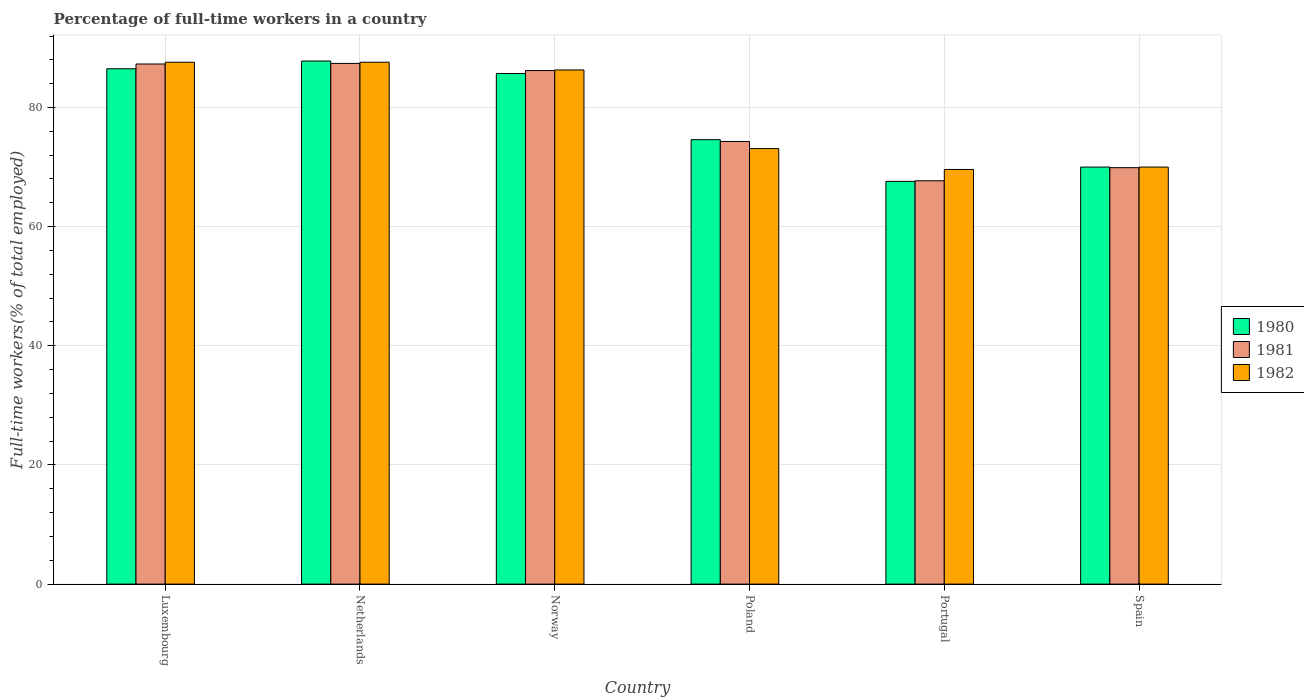How many groups of bars are there?
Provide a short and direct response. 6. Are the number of bars on each tick of the X-axis equal?
Keep it short and to the point. Yes. How many bars are there on the 2nd tick from the left?
Give a very brief answer. 3. What is the percentage of full-time workers in 1981 in Luxembourg?
Offer a very short reply. 87.3. Across all countries, what is the maximum percentage of full-time workers in 1981?
Provide a short and direct response. 87.4. Across all countries, what is the minimum percentage of full-time workers in 1982?
Keep it short and to the point. 69.6. In which country was the percentage of full-time workers in 1980 minimum?
Your answer should be compact. Portugal. What is the total percentage of full-time workers in 1980 in the graph?
Your response must be concise. 472.2. What is the difference between the percentage of full-time workers in 1981 in Luxembourg and that in Spain?
Offer a very short reply. 17.4. What is the difference between the percentage of full-time workers in 1980 in Portugal and the percentage of full-time workers in 1981 in Netherlands?
Give a very brief answer. -19.8. What is the average percentage of full-time workers in 1980 per country?
Provide a succinct answer. 78.7. What is the difference between the percentage of full-time workers of/in 1980 and percentage of full-time workers of/in 1981 in Poland?
Your answer should be compact. 0.3. What is the ratio of the percentage of full-time workers in 1981 in Poland to that in Spain?
Provide a short and direct response. 1.06. What is the difference between the highest and the second highest percentage of full-time workers in 1980?
Your answer should be very brief. -0.8. What is the difference between the highest and the lowest percentage of full-time workers in 1980?
Provide a short and direct response. 20.2. What does the 2nd bar from the left in Poland represents?
Provide a short and direct response. 1981. Are all the bars in the graph horizontal?
Offer a terse response. No. What is the title of the graph?
Your response must be concise. Percentage of full-time workers in a country. Does "1980" appear as one of the legend labels in the graph?
Provide a short and direct response. Yes. What is the label or title of the X-axis?
Provide a short and direct response. Country. What is the label or title of the Y-axis?
Provide a succinct answer. Full-time workers(% of total employed). What is the Full-time workers(% of total employed) of 1980 in Luxembourg?
Your answer should be compact. 86.5. What is the Full-time workers(% of total employed) of 1981 in Luxembourg?
Make the answer very short. 87.3. What is the Full-time workers(% of total employed) in 1982 in Luxembourg?
Offer a very short reply. 87.6. What is the Full-time workers(% of total employed) in 1980 in Netherlands?
Offer a very short reply. 87.8. What is the Full-time workers(% of total employed) in 1981 in Netherlands?
Your answer should be very brief. 87.4. What is the Full-time workers(% of total employed) of 1982 in Netherlands?
Keep it short and to the point. 87.6. What is the Full-time workers(% of total employed) of 1980 in Norway?
Offer a terse response. 85.7. What is the Full-time workers(% of total employed) in 1981 in Norway?
Provide a succinct answer. 86.2. What is the Full-time workers(% of total employed) in 1982 in Norway?
Make the answer very short. 86.3. What is the Full-time workers(% of total employed) in 1980 in Poland?
Your answer should be compact. 74.6. What is the Full-time workers(% of total employed) in 1981 in Poland?
Provide a short and direct response. 74.3. What is the Full-time workers(% of total employed) in 1982 in Poland?
Ensure brevity in your answer.  73.1. What is the Full-time workers(% of total employed) of 1980 in Portugal?
Offer a very short reply. 67.6. What is the Full-time workers(% of total employed) of 1981 in Portugal?
Keep it short and to the point. 67.7. What is the Full-time workers(% of total employed) of 1982 in Portugal?
Ensure brevity in your answer.  69.6. What is the Full-time workers(% of total employed) of 1980 in Spain?
Give a very brief answer. 70. What is the Full-time workers(% of total employed) in 1981 in Spain?
Your answer should be very brief. 69.9. What is the Full-time workers(% of total employed) of 1982 in Spain?
Make the answer very short. 70. Across all countries, what is the maximum Full-time workers(% of total employed) of 1980?
Offer a very short reply. 87.8. Across all countries, what is the maximum Full-time workers(% of total employed) in 1981?
Make the answer very short. 87.4. Across all countries, what is the maximum Full-time workers(% of total employed) of 1982?
Your answer should be very brief. 87.6. Across all countries, what is the minimum Full-time workers(% of total employed) in 1980?
Your answer should be compact. 67.6. Across all countries, what is the minimum Full-time workers(% of total employed) of 1981?
Provide a succinct answer. 67.7. Across all countries, what is the minimum Full-time workers(% of total employed) in 1982?
Offer a very short reply. 69.6. What is the total Full-time workers(% of total employed) of 1980 in the graph?
Give a very brief answer. 472.2. What is the total Full-time workers(% of total employed) of 1981 in the graph?
Ensure brevity in your answer.  472.8. What is the total Full-time workers(% of total employed) in 1982 in the graph?
Keep it short and to the point. 474.2. What is the difference between the Full-time workers(% of total employed) in 1981 in Luxembourg and that in Netherlands?
Your response must be concise. -0.1. What is the difference between the Full-time workers(% of total employed) in 1982 in Luxembourg and that in Netherlands?
Give a very brief answer. 0. What is the difference between the Full-time workers(% of total employed) of 1981 in Luxembourg and that in Poland?
Your answer should be very brief. 13. What is the difference between the Full-time workers(% of total employed) of 1982 in Luxembourg and that in Poland?
Your answer should be compact. 14.5. What is the difference between the Full-time workers(% of total employed) of 1981 in Luxembourg and that in Portugal?
Offer a very short reply. 19.6. What is the difference between the Full-time workers(% of total employed) of 1982 in Luxembourg and that in Portugal?
Your answer should be very brief. 18. What is the difference between the Full-time workers(% of total employed) in 1981 in Luxembourg and that in Spain?
Offer a very short reply. 17.4. What is the difference between the Full-time workers(% of total employed) in 1980 in Netherlands and that in Norway?
Offer a very short reply. 2.1. What is the difference between the Full-time workers(% of total employed) in 1981 in Netherlands and that in Norway?
Provide a succinct answer. 1.2. What is the difference between the Full-time workers(% of total employed) of 1982 in Netherlands and that in Norway?
Provide a short and direct response. 1.3. What is the difference between the Full-time workers(% of total employed) of 1980 in Netherlands and that in Poland?
Your answer should be very brief. 13.2. What is the difference between the Full-time workers(% of total employed) of 1981 in Netherlands and that in Poland?
Offer a terse response. 13.1. What is the difference between the Full-time workers(% of total employed) of 1982 in Netherlands and that in Poland?
Your answer should be compact. 14.5. What is the difference between the Full-time workers(% of total employed) in 1980 in Netherlands and that in Portugal?
Your response must be concise. 20.2. What is the difference between the Full-time workers(% of total employed) of 1981 in Netherlands and that in Portugal?
Provide a short and direct response. 19.7. What is the difference between the Full-time workers(% of total employed) of 1982 in Netherlands and that in Portugal?
Give a very brief answer. 18. What is the difference between the Full-time workers(% of total employed) in 1982 in Netherlands and that in Spain?
Provide a succinct answer. 17.6. What is the difference between the Full-time workers(% of total employed) in 1981 in Norway and that in Poland?
Provide a succinct answer. 11.9. What is the difference between the Full-time workers(% of total employed) of 1981 in Norway and that in Portugal?
Provide a succinct answer. 18.5. What is the difference between the Full-time workers(% of total employed) of 1982 in Poland and that in Portugal?
Keep it short and to the point. 3.5. What is the difference between the Full-time workers(% of total employed) in 1980 in Poland and that in Spain?
Your answer should be very brief. 4.6. What is the difference between the Full-time workers(% of total employed) in 1981 in Poland and that in Spain?
Make the answer very short. 4.4. What is the difference between the Full-time workers(% of total employed) in 1981 in Portugal and that in Spain?
Ensure brevity in your answer.  -2.2. What is the difference between the Full-time workers(% of total employed) of 1982 in Portugal and that in Spain?
Your answer should be compact. -0.4. What is the difference between the Full-time workers(% of total employed) in 1980 in Luxembourg and the Full-time workers(% of total employed) in 1982 in Portugal?
Give a very brief answer. 16.9. What is the difference between the Full-time workers(% of total employed) in 1980 in Luxembourg and the Full-time workers(% of total employed) in 1981 in Spain?
Give a very brief answer. 16.6. What is the difference between the Full-time workers(% of total employed) in 1980 in Netherlands and the Full-time workers(% of total employed) in 1982 in Poland?
Make the answer very short. 14.7. What is the difference between the Full-time workers(% of total employed) of 1981 in Netherlands and the Full-time workers(% of total employed) of 1982 in Poland?
Provide a short and direct response. 14.3. What is the difference between the Full-time workers(% of total employed) in 1980 in Netherlands and the Full-time workers(% of total employed) in 1981 in Portugal?
Make the answer very short. 20.1. What is the difference between the Full-time workers(% of total employed) in 1980 in Netherlands and the Full-time workers(% of total employed) in 1982 in Spain?
Give a very brief answer. 17.8. What is the difference between the Full-time workers(% of total employed) of 1980 in Norway and the Full-time workers(% of total employed) of 1982 in Poland?
Offer a very short reply. 12.6. What is the difference between the Full-time workers(% of total employed) of 1981 in Norway and the Full-time workers(% of total employed) of 1982 in Poland?
Provide a short and direct response. 13.1. What is the difference between the Full-time workers(% of total employed) in 1980 in Norway and the Full-time workers(% of total employed) in 1981 in Portugal?
Your answer should be very brief. 18. What is the difference between the Full-time workers(% of total employed) in 1981 in Norway and the Full-time workers(% of total employed) in 1982 in Portugal?
Give a very brief answer. 16.6. What is the difference between the Full-time workers(% of total employed) in 1980 in Norway and the Full-time workers(% of total employed) in 1981 in Spain?
Offer a very short reply. 15.8. What is the difference between the Full-time workers(% of total employed) of 1980 in Norway and the Full-time workers(% of total employed) of 1982 in Spain?
Provide a succinct answer. 15.7. What is the difference between the Full-time workers(% of total employed) in 1981 in Norway and the Full-time workers(% of total employed) in 1982 in Spain?
Make the answer very short. 16.2. What is the difference between the Full-time workers(% of total employed) of 1980 in Poland and the Full-time workers(% of total employed) of 1982 in Portugal?
Offer a terse response. 5. What is the difference between the Full-time workers(% of total employed) in 1981 in Poland and the Full-time workers(% of total employed) in 1982 in Portugal?
Your answer should be compact. 4.7. What is the difference between the Full-time workers(% of total employed) of 1980 in Poland and the Full-time workers(% of total employed) of 1981 in Spain?
Give a very brief answer. 4.7. What is the difference between the Full-time workers(% of total employed) of 1980 in Poland and the Full-time workers(% of total employed) of 1982 in Spain?
Provide a short and direct response. 4.6. What is the difference between the Full-time workers(% of total employed) in 1980 in Portugal and the Full-time workers(% of total employed) in 1981 in Spain?
Your answer should be very brief. -2.3. What is the difference between the Full-time workers(% of total employed) of 1980 in Portugal and the Full-time workers(% of total employed) of 1982 in Spain?
Offer a terse response. -2.4. What is the difference between the Full-time workers(% of total employed) in 1981 in Portugal and the Full-time workers(% of total employed) in 1982 in Spain?
Provide a short and direct response. -2.3. What is the average Full-time workers(% of total employed) in 1980 per country?
Ensure brevity in your answer.  78.7. What is the average Full-time workers(% of total employed) in 1981 per country?
Your answer should be very brief. 78.8. What is the average Full-time workers(% of total employed) of 1982 per country?
Ensure brevity in your answer.  79.03. What is the difference between the Full-time workers(% of total employed) of 1980 and Full-time workers(% of total employed) of 1981 in Luxembourg?
Provide a short and direct response. -0.8. What is the difference between the Full-time workers(% of total employed) of 1980 and Full-time workers(% of total employed) of 1982 in Luxembourg?
Provide a succinct answer. -1.1. What is the difference between the Full-time workers(% of total employed) of 1981 and Full-time workers(% of total employed) of 1982 in Luxembourg?
Ensure brevity in your answer.  -0.3. What is the difference between the Full-time workers(% of total employed) in 1981 and Full-time workers(% of total employed) in 1982 in Netherlands?
Your answer should be compact. -0.2. What is the difference between the Full-time workers(% of total employed) in 1981 and Full-time workers(% of total employed) in 1982 in Norway?
Ensure brevity in your answer.  -0.1. What is the difference between the Full-time workers(% of total employed) in 1980 and Full-time workers(% of total employed) in 1982 in Poland?
Provide a short and direct response. 1.5. What is the difference between the Full-time workers(% of total employed) of 1980 and Full-time workers(% of total employed) of 1982 in Portugal?
Your response must be concise. -2. What is the difference between the Full-time workers(% of total employed) in 1981 and Full-time workers(% of total employed) in 1982 in Portugal?
Make the answer very short. -1.9. What is the ratio of the Full-time workers(% of total employed) of 1980 in Luxembourg to that in Netherlands?
Provide a short and direct response. 0.99. What is the ratio of the Full-time workers(% of total employed) in 1981 in Luxembourg to that in Netherlands?
Your answer should be very brief. 1. What is the ratio of the Full-time workers(% of total employed) of 1982 in Luxembourg to that in Netherlands?
Keep it short and to the point. 1. What is the ratio of the Full-time workers(% of total employed) in 1980 in Luxembourg to that in Norway?
Offer a very short reply. 1.01. What is the ratio of the Full-time workers(% of total employed) in 1981 in Luxembourg to that in Norway?
Offer a very short reply. 1.01. What is the ratio of the Full-time workers(% of total employed) of 1982 in Luxembourg to that in Norway?
Offer a terse response. 1.02. What is the ratio of the Full-time workers(% of total employed) of 1980 in Luxembourg to that in Poland?
Your answer should be very brief. 1.16. What is the ratio of the Full-time workers(% of total employed) of 1981 in Luxembourg to that in Poland?
Your answer should be very brief. 1.18. What is the ratio of the Full-time workers(% of total employed) of 1982 in Luxembourg to that in Poland?
Provide a succinct answer. 1.2. What is the ratio of the Full-time workers(% of total employed) of 1980 in Luxembourg to that in Portugal?
Your answer should be compact. 1.28. What is the ratio of the Full-time workers(% of total employed) of 1981 in Luxembourg to that in Portugal?
Provide a succinct answer. 1.29. What is the ratio of the Full-time workers(% of total employed) in 1982 in Luxembourg to that in Portugal?
Provide a succinct answer. 1.26. What is the ratio of the Full-time workers(% of total employed) in 1980 in Luxembourg to that in Spain?
Provide a short and direct response. 1.24. What is the ratio of the Full-time workers(% of total employed) of 1981 in Luxembourg to that in Spain?
Your answer should be very brief. 1.25. What is the ratio of the Full-time workers(% of total employed) in 1982 in Luxembourg to that in Spain?
Provide a succinct answer. 1.25. What is the ratio of the Full-time workers(% of total employed) in 1980 in Netherlands to that in Norway?
Your answer should be very brief. 1.02. What is the ratio of the Full-time workers(% of total employed) of 1981 in Netherlands to that in Norway?
Provide a succinct answer. 1.01. What is the ratio of the Full-time workers(% of total employed) of 1982 in Netherlands to that in Norway?
Keep it short and to the point. 1.02. What is the ratio of the Full-time workers(% of total employed) of 1980 in Netherlands to that in Poland?
Your answer should be compact. 1.18. What is the ratio of the Full-time workers(% of total employed) in 1981 in Netherlands to that in Poland?
Your response must be concise. 1.18. What is the ratio of the Full-time workers(% of total employed) in 1982 in Netherlands to that in Poland?
Make the answer very short. 1.2. What is the ratio of the Full-time workers(% of total employed) in 1980 in Netherlands to that in Portugal?
Ensure brevity in your answer.  1.3. What is the ratio of the Full-time workers(% of total employed) in 1981 in Netherlands to that in Portugal?
Make the answer very short. 1.29. What is the ratio of the Full-time workers(% of total employed) in 1982 in Netherlands to that in Portugal?
Provide a short and direct response. 1.26. What is the ratio of the Full-time workers(% of total employed) in 1980 in Netherlands to that in Spain?
Offer a terse response. 1.25. What is the ratio of the Full-time workers(% of total employed) in 1981 in Netherlands to that in Spain?
Make the answer very short. 1.25. What is the ratio of the Full-time workers(% of total employed) in 1982 in Netherlands to that in Spain?
Offer a very short reply. 1.25. What is the ratio of the Full-time workers(% of total employed) in 1980 in Norway to that in Poland?
Your answer should be compact. 1.15. What is the ratio of the Full-time workers(% of total employed) of 1981 in Norway to that in Poland?
Your answer should be compact. 1.16. What is the ratio of the Full-time workers(% of total employed) of 1982 in Norway to that in Poland?
Your answer should be compact. 1.18. What is the ratio of the Full-time workers(% of total employed) of 1980 in Norway to that in Portugal?
Make the answer very short. 1.27. What is the ratio of the Full-time workers(% of total employed) of 1981 in Norway to that in Portugal?
Your response must be concise. 1.27. What is the ratio of the Full-time workers(% of total employed) in 1982 in Norway to that in Portugal?
Ensure brevity in your answer.  1.24. What is the ratio of the Full-time workers(% of total employed) of 1980 in Norway to that in Spain?
Keep it short and to the point. 1.22. What is the ratio of the Full-time workers(% of total employed) of 1981 in Norway to that in Spain?
Provide a succinct answer. 1.23. What is the ratio of the Full-time workers(% of total employed) of 1982 in Norway to that in Spain?
Your answer should be compact. 1.23. What is the ratio of the Full-time workers(% of total employed) of 1980 in Poland to that in Portugal?
Your response must be concise. 1.1. What is the ratio of the Full-time workers(% of total employed) of 1981 in Poland to that in Portugal?
Provide a short and direct response. 1.1. What is the ratio of the Full-time workers(% of total employed) in 1982 in Poland to that in Portugal?
Provide a succinct answer. 1.05. What is the ratio of the Full-time workers(% of total employed) in 1980 in Poland to that in Spain?
Offer a terse response. 1.07. What is the ratio of the Full-time workers(% of total employed) of 1981 in Poland to that in Spain?
Keep it short and to the point. 1.06. What is the ratio of the Full-time workers(% of total employed) of 1982 in Poland to that in Spain?
Offer a terse response. 1.04. What is the ratio of the Full-time workers(% of total employed) of 1980 in Portugal to that in Spain?
Offer a terse response. 0.97. What is the ratio of the Full-time workers(% of total employed) in 1981 in Portugal to that in Spain?
Your answer should be compact. 0.97. What is the difference between the highest and the second highest Full-time workers(% of total employed) in 1982?
Ensure brevity in your answer.  0. What is the difference between the highest and the lowest Full-time workers(% of total employed) in 1980?
Your response must be concise. 20.2. What is the difference between the highest and the lowest Full-time workers(% of total employed) of 1981?
Your response must be concise. 19.7. 